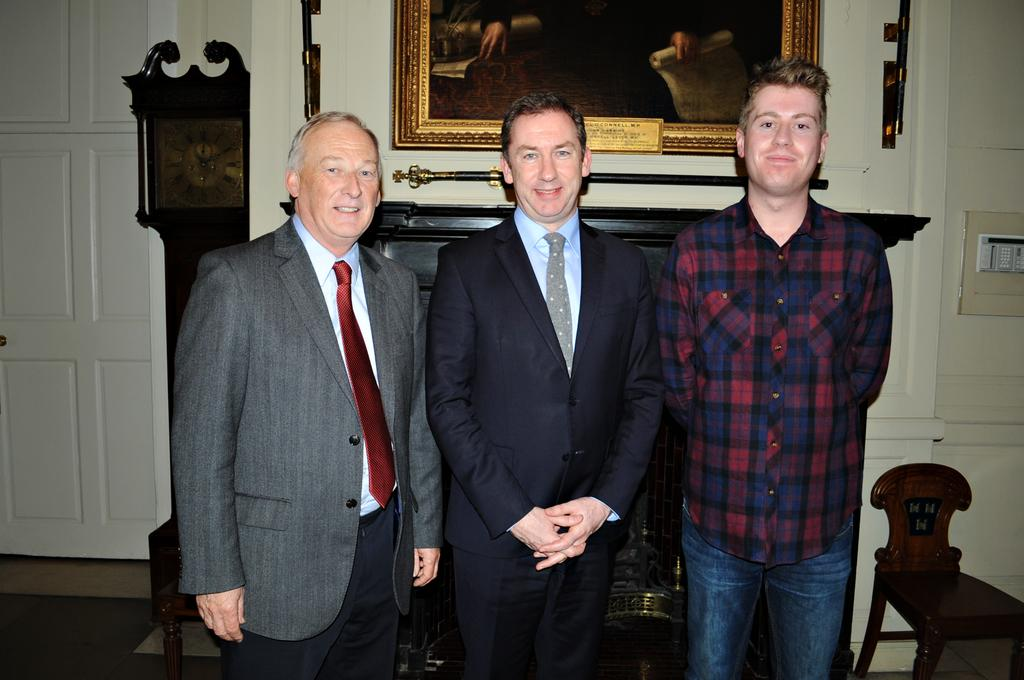How many people are in the image? There are three people standing in the image. What are the people doing in the image? The people are posing for a picture. What can be seen in the background of the image? There is a wall, a wall posture, a clock, and a chair in the background of the image. What type of screw is holding the company's logo on the wall in the image? There is no screw or company logo present in the image. What color is the ink used for the company's name on the wall in the image? There is no company name or ink present in the image. 